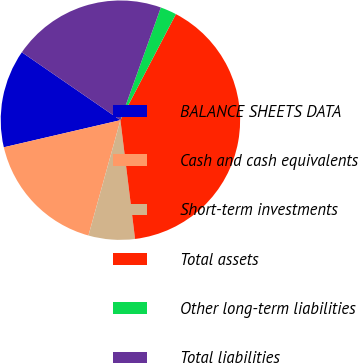Convert chart to OTSL. <chart><loc_0><loc_0><loc_500><loc_500><pie_chart><fcel>BALANCE SHEETS DATA<fcel>Cash and cash equivalents<fcel>Short-term investments<fcel>Total assets<fcel>Other long-term liabilities<fcel>Total liabilities<nl><fcel>13.24%<fcel>17.06%<fcel>6.26%<fcel>40.38%<fcel>2.19%<fcel>20.88%<nl></chart> 